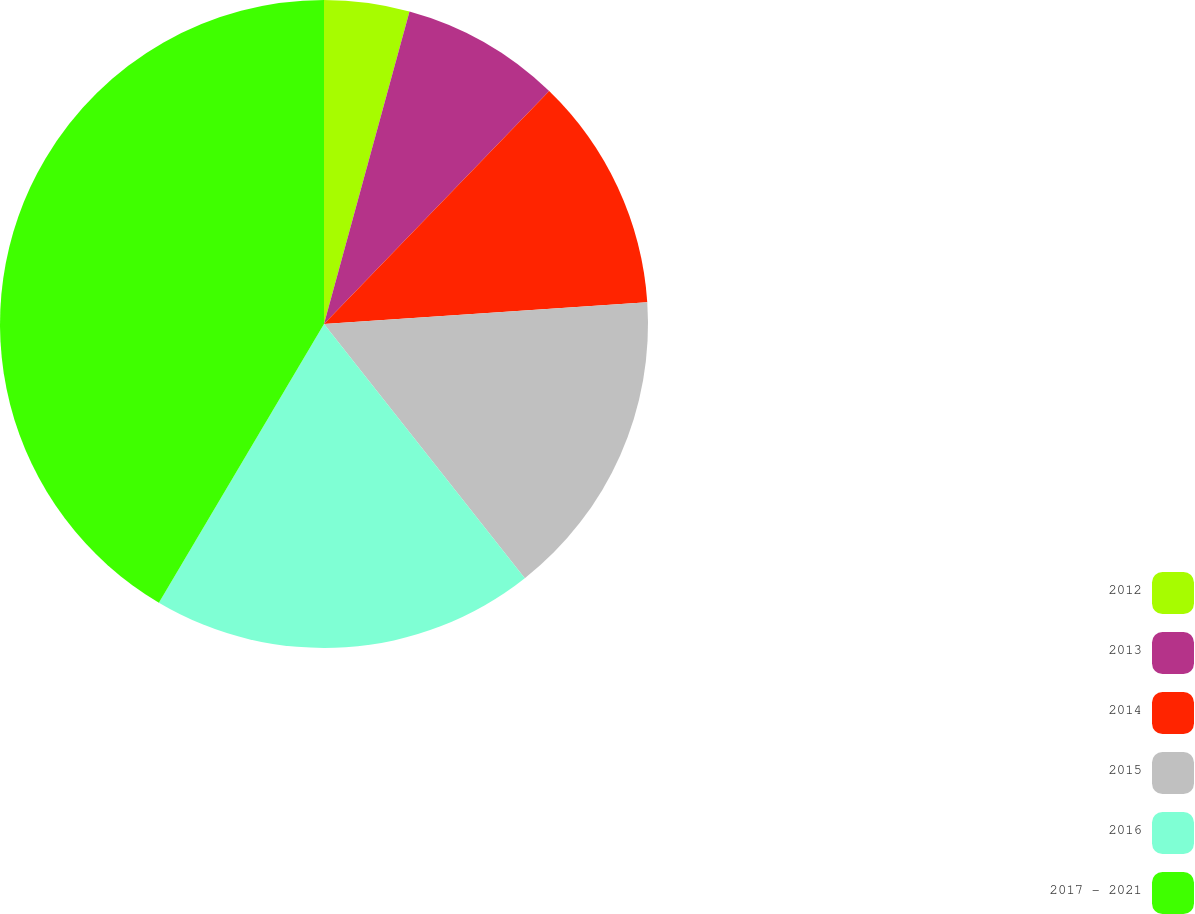<chart> <loc_0><loc_0><loc_500><loc_500><pie_chart><fcel>2012<fcel>2013<fcel>2014<fcel>2015<fcel>2016<fcel>2017 - 2021<nl><fcel>4.25%<fcel>7.98%<fcel>11.7%<fcel>15.43%<fcel>19.15%<fcel>41.49%<nl></chart> 